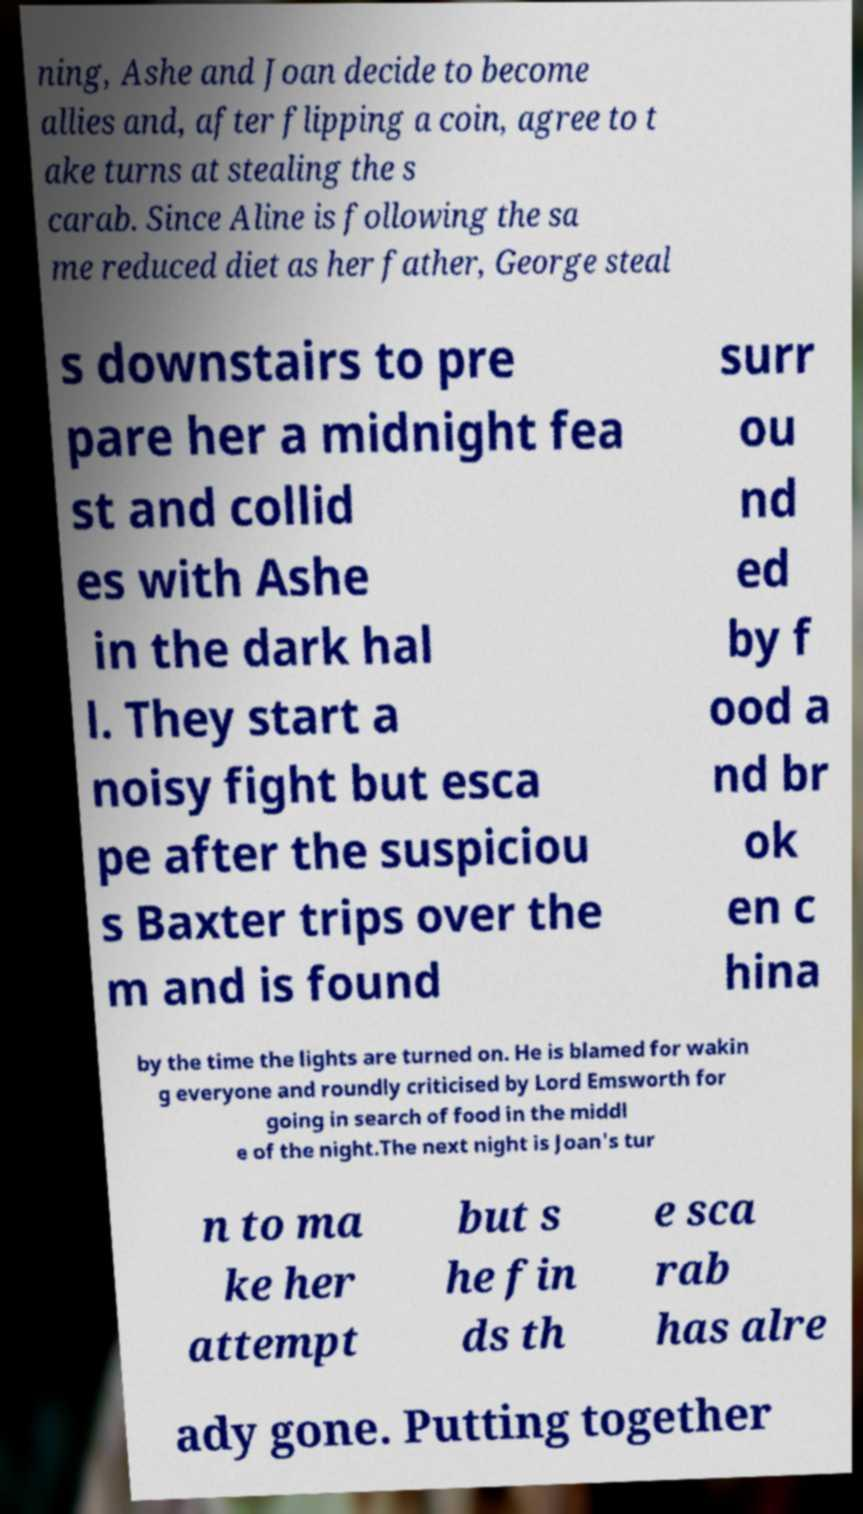Can you accurately transcribe the text from the provided image for me? ning, Ashe and Joan decide to become allies and, after flipping a coin, agree to t ake turns at stealing the s carab. Since Aline is following the sa me reduced diet as her father, George steal s downstairs to pre pare her a midnight fea st and collid es with Ashe in the dark hal l. They start a noisy fight but esca pe after the suspiciou s Baxter trips over the m and is found surr ou nd ed by f ood a nd br ok en c hina by the time the lights are turned on. He is blamed for wakin g everyone and roundly criticised by Lord Emsworth for going in search of food in the middl e of the night.The next night is Joan's tur n to ma ke her attempt but s he fin ds th e sca rab has alre ady gone. Putting together 